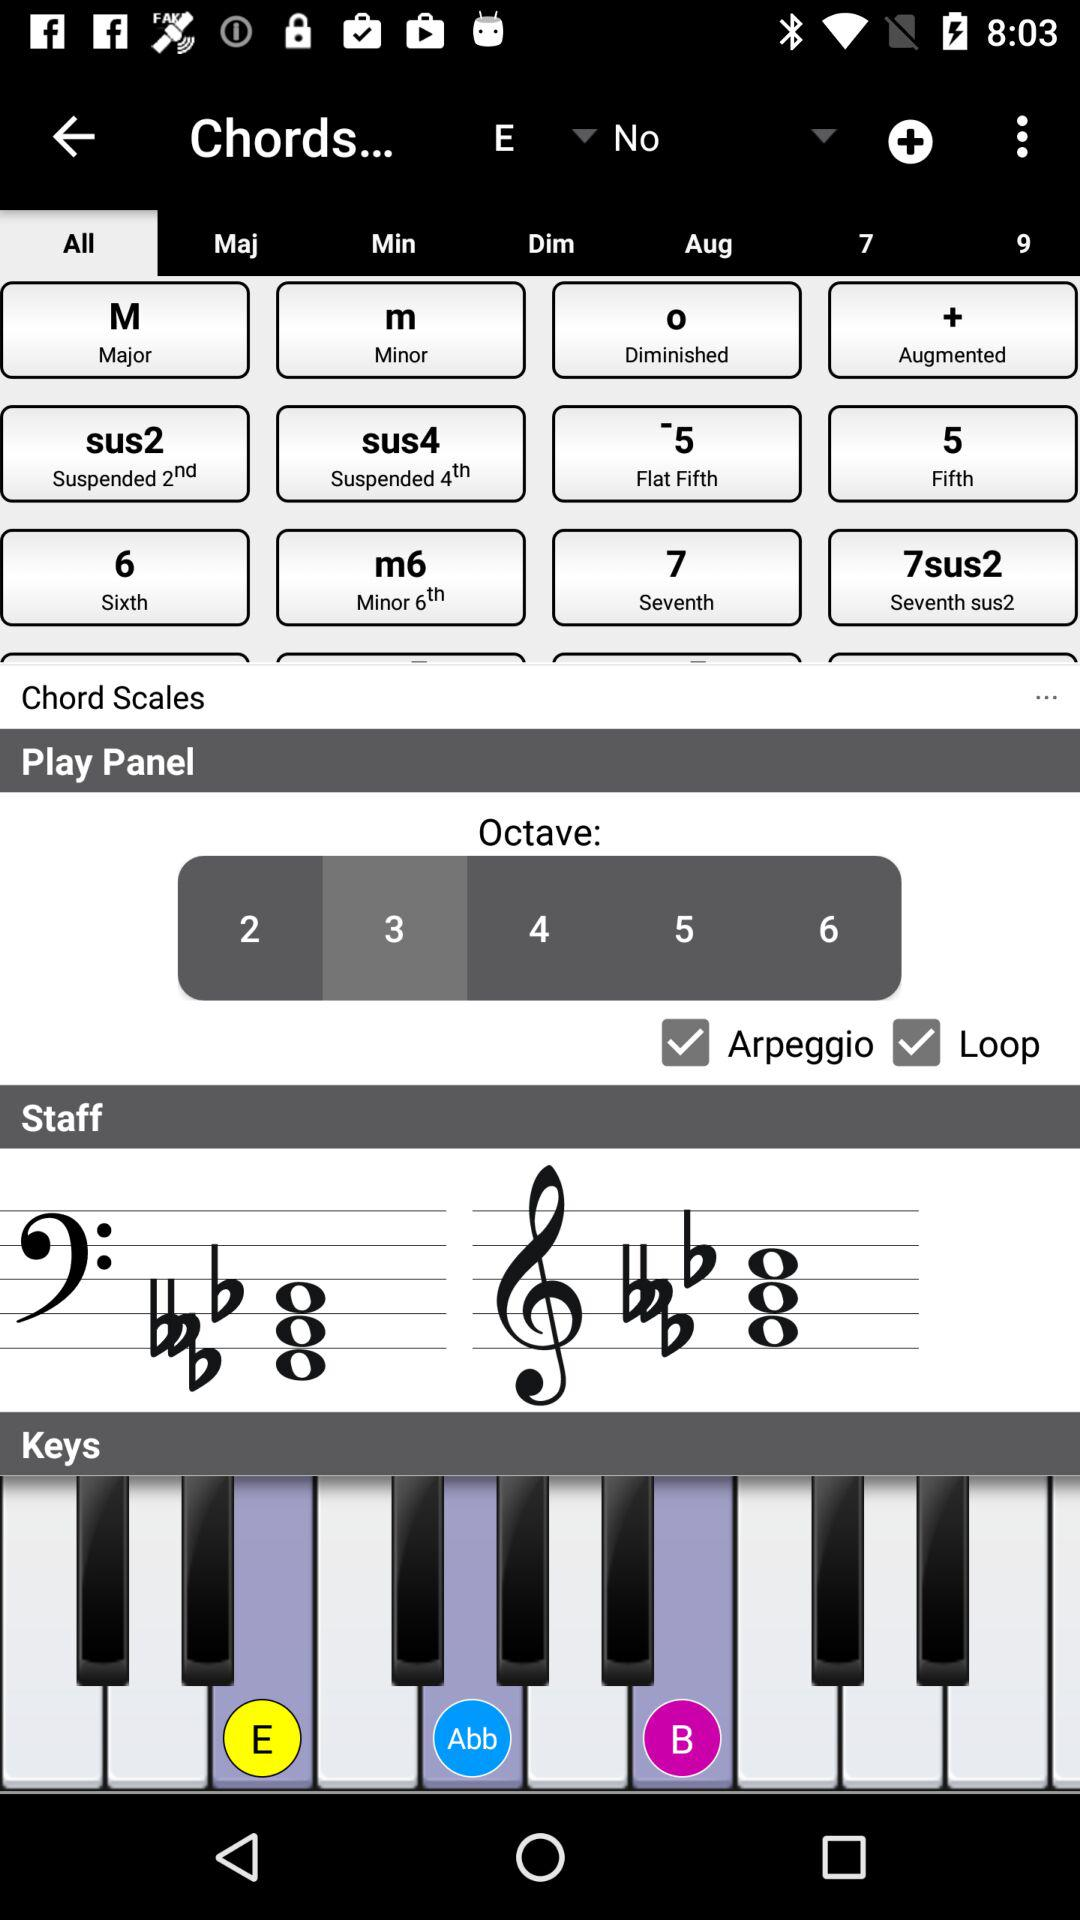Which tab is selected? The selected tab is "All". 